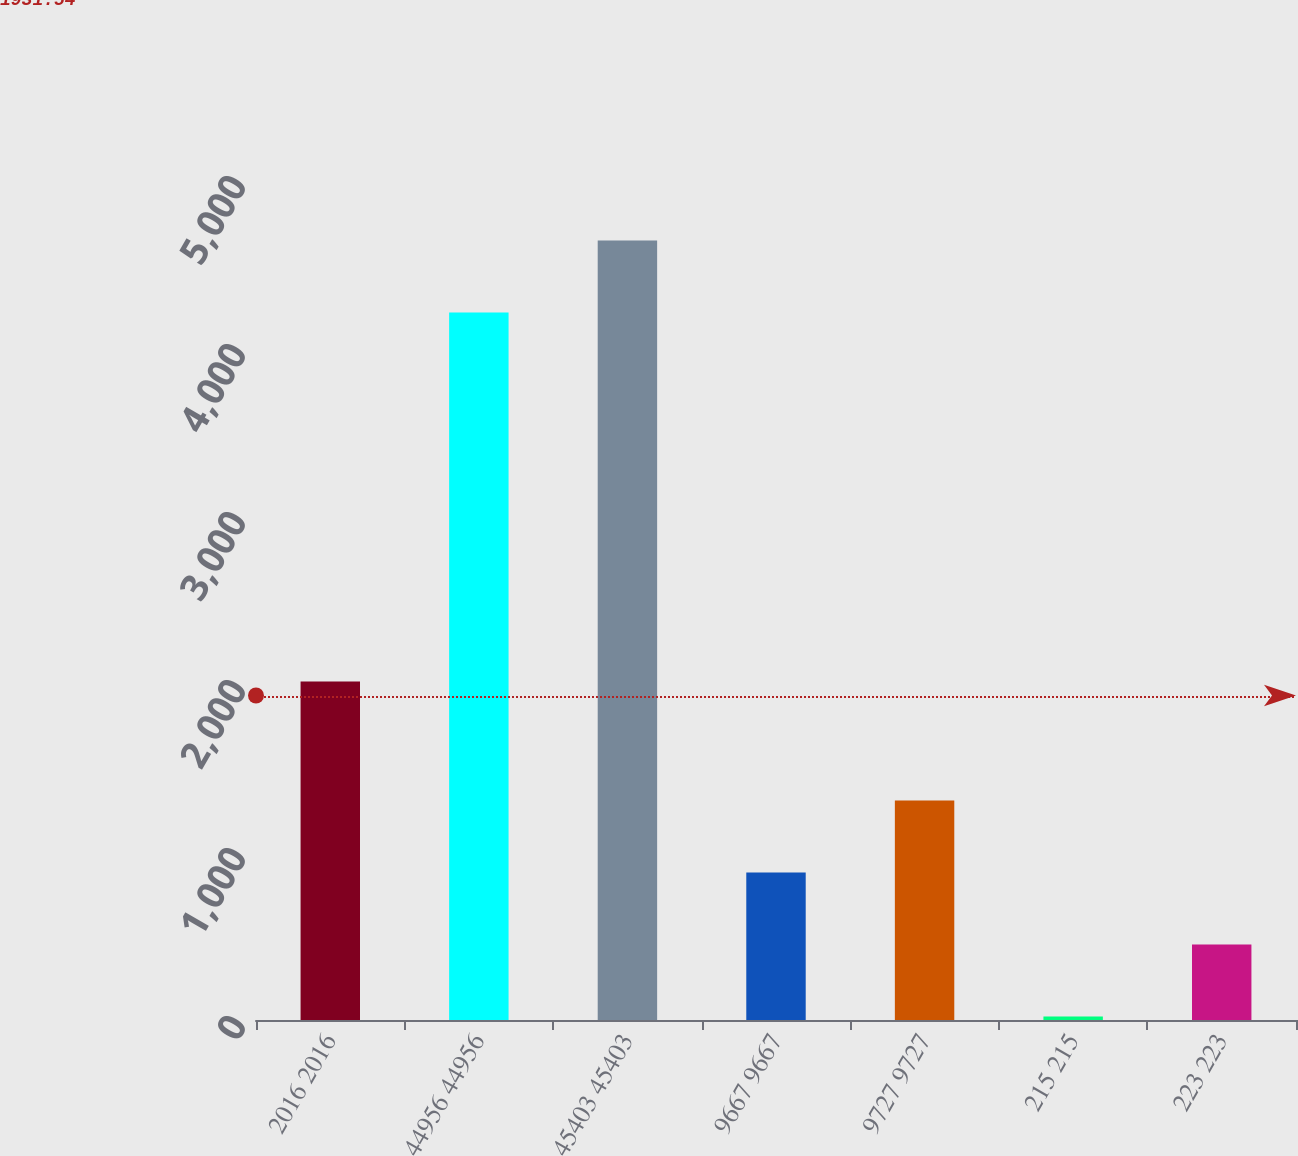Convert chart. <chart><loc_0><loc_0><loc_500><loc_500><bar_chart><fcel>2016 2016<fcel>44956 44956<fcel>45403 45403<fcel>9667 9667<fcel>9727 9727<fcel>215 215<fcel>223 223<nl><fcel>2015<fcel>4210.9<fcel>4639.58<fcel>878.16<fcel>1306.84<fcel>20.8<fcel>449.48<nl></chart> 